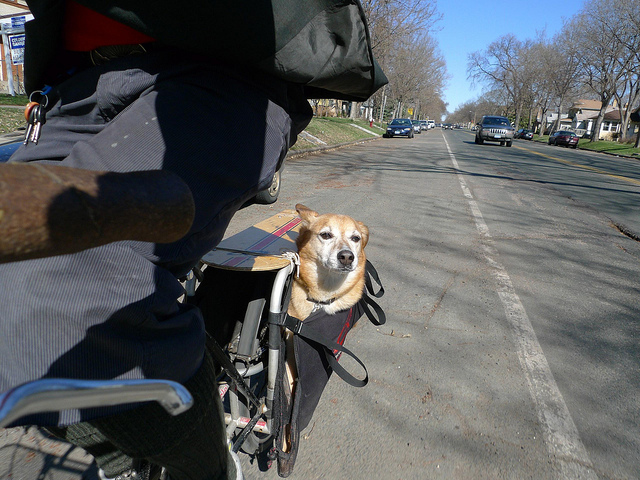How is the dog probably traveling?
A. motorcycle
B. bike
C. scooter
D. skateboard
Answer with the option's letter from the given choices directly. B 